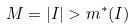<formula> <loc_0><loc_0><loc_500><loc_500>M = | I | > m ^ { * } ( I )</formula> 